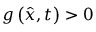<formula> <loc_0><loc_0><loc_500><loc_500>g \left ( { \hat { x } } , t \right ) > 0</formula> 